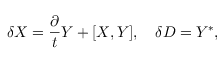<formula> <loc_0><loc_0><loc_500><loc_500>\delta X = \frac { \partial } { t } Y + [ X , Y ] , \quad \delta D = Y ^ { * } ,</formula> 